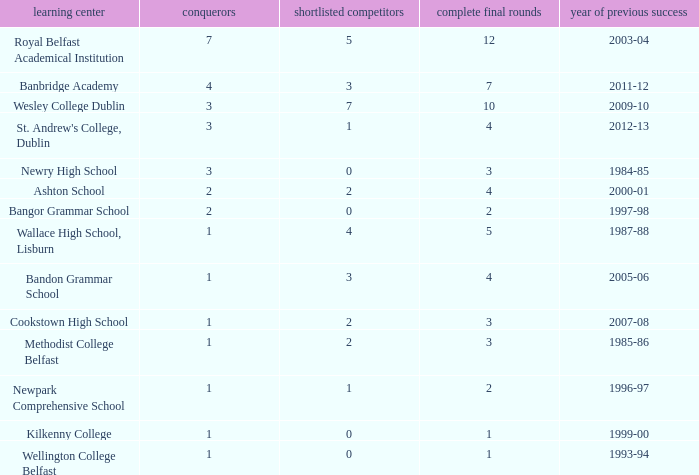How many total finals where there when the last win was in 2012-13? 4.0. 